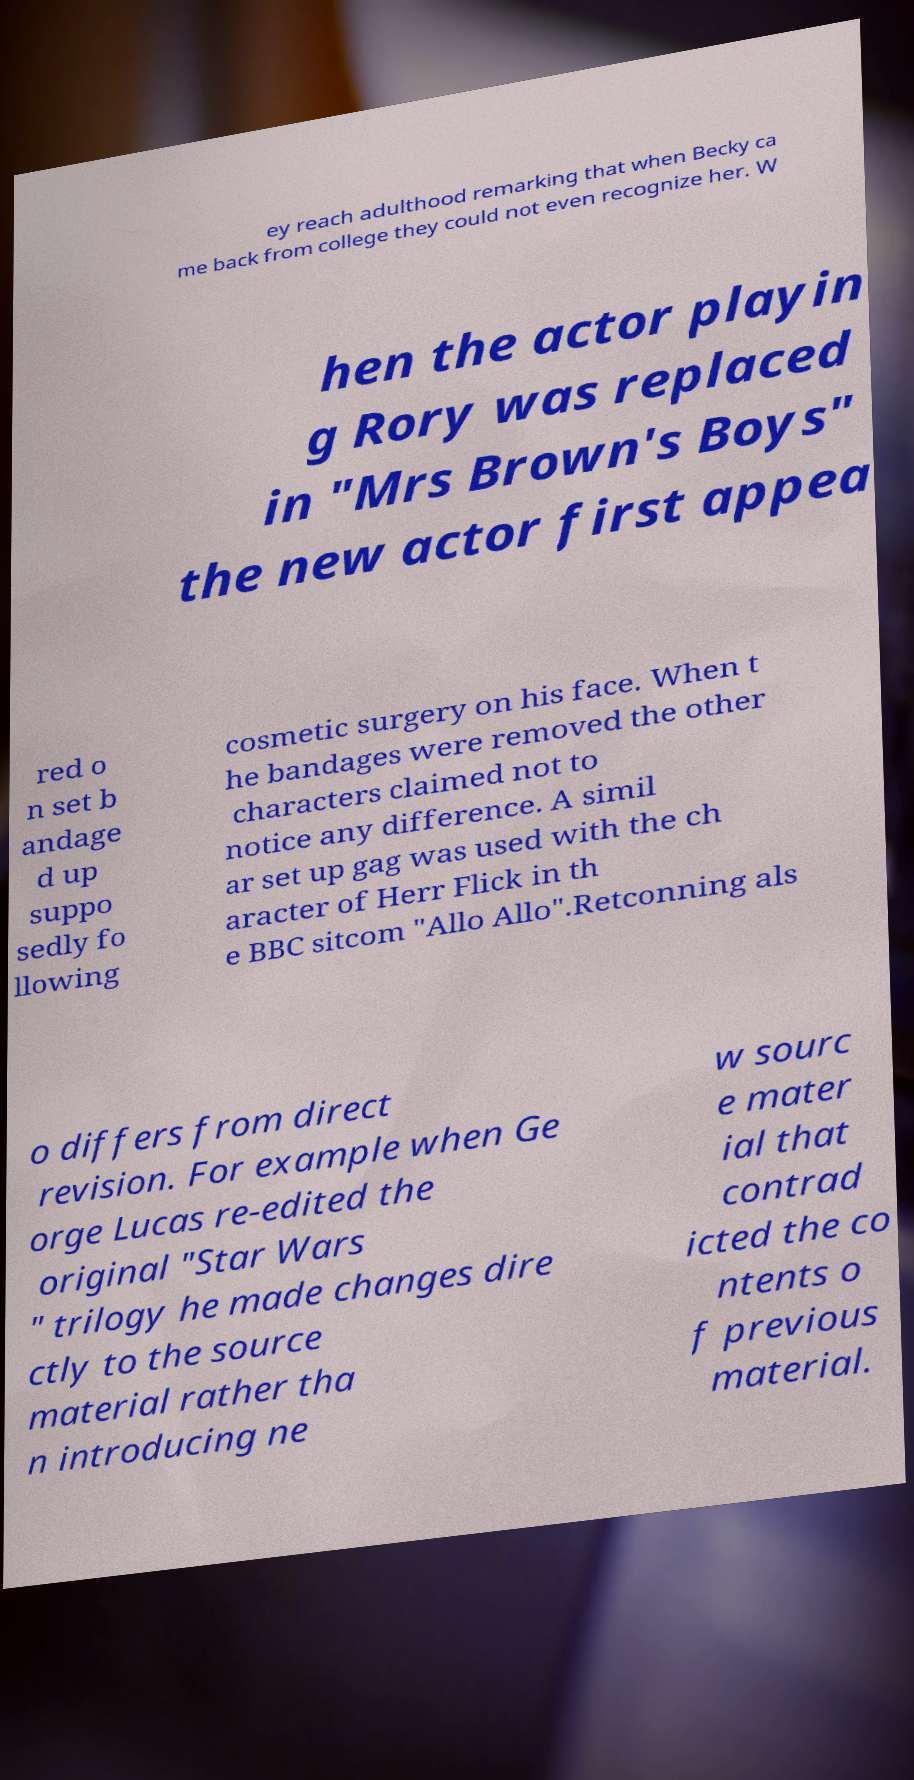What messages or text are displayed in this image? I need them in a readable, typed format. ey reach adulthood remarking that when Becky ca me back from college they could not even recognize her. W hen the actor playin g Rory was replaced in "Mrs Brown's Boys" the new actor first appea red o n set b andage d up suppo sedly fo llowing cosmetic surgery on his face. When t he bandages were removed the other characters claimed not to notice any difference. A simil ar set up gag was used with the ch aracter of Herr Flick in th e BBC sitcom "Allo Allo".Retconning als o differs from direct revision. For example when Ge orge Lucas re-edited the original "Star Wars " trilogy he made changes dire ctly to the source material rather tha n introducing ne w sourc e mater ial that contrad icted the co ntents o f previous material. 